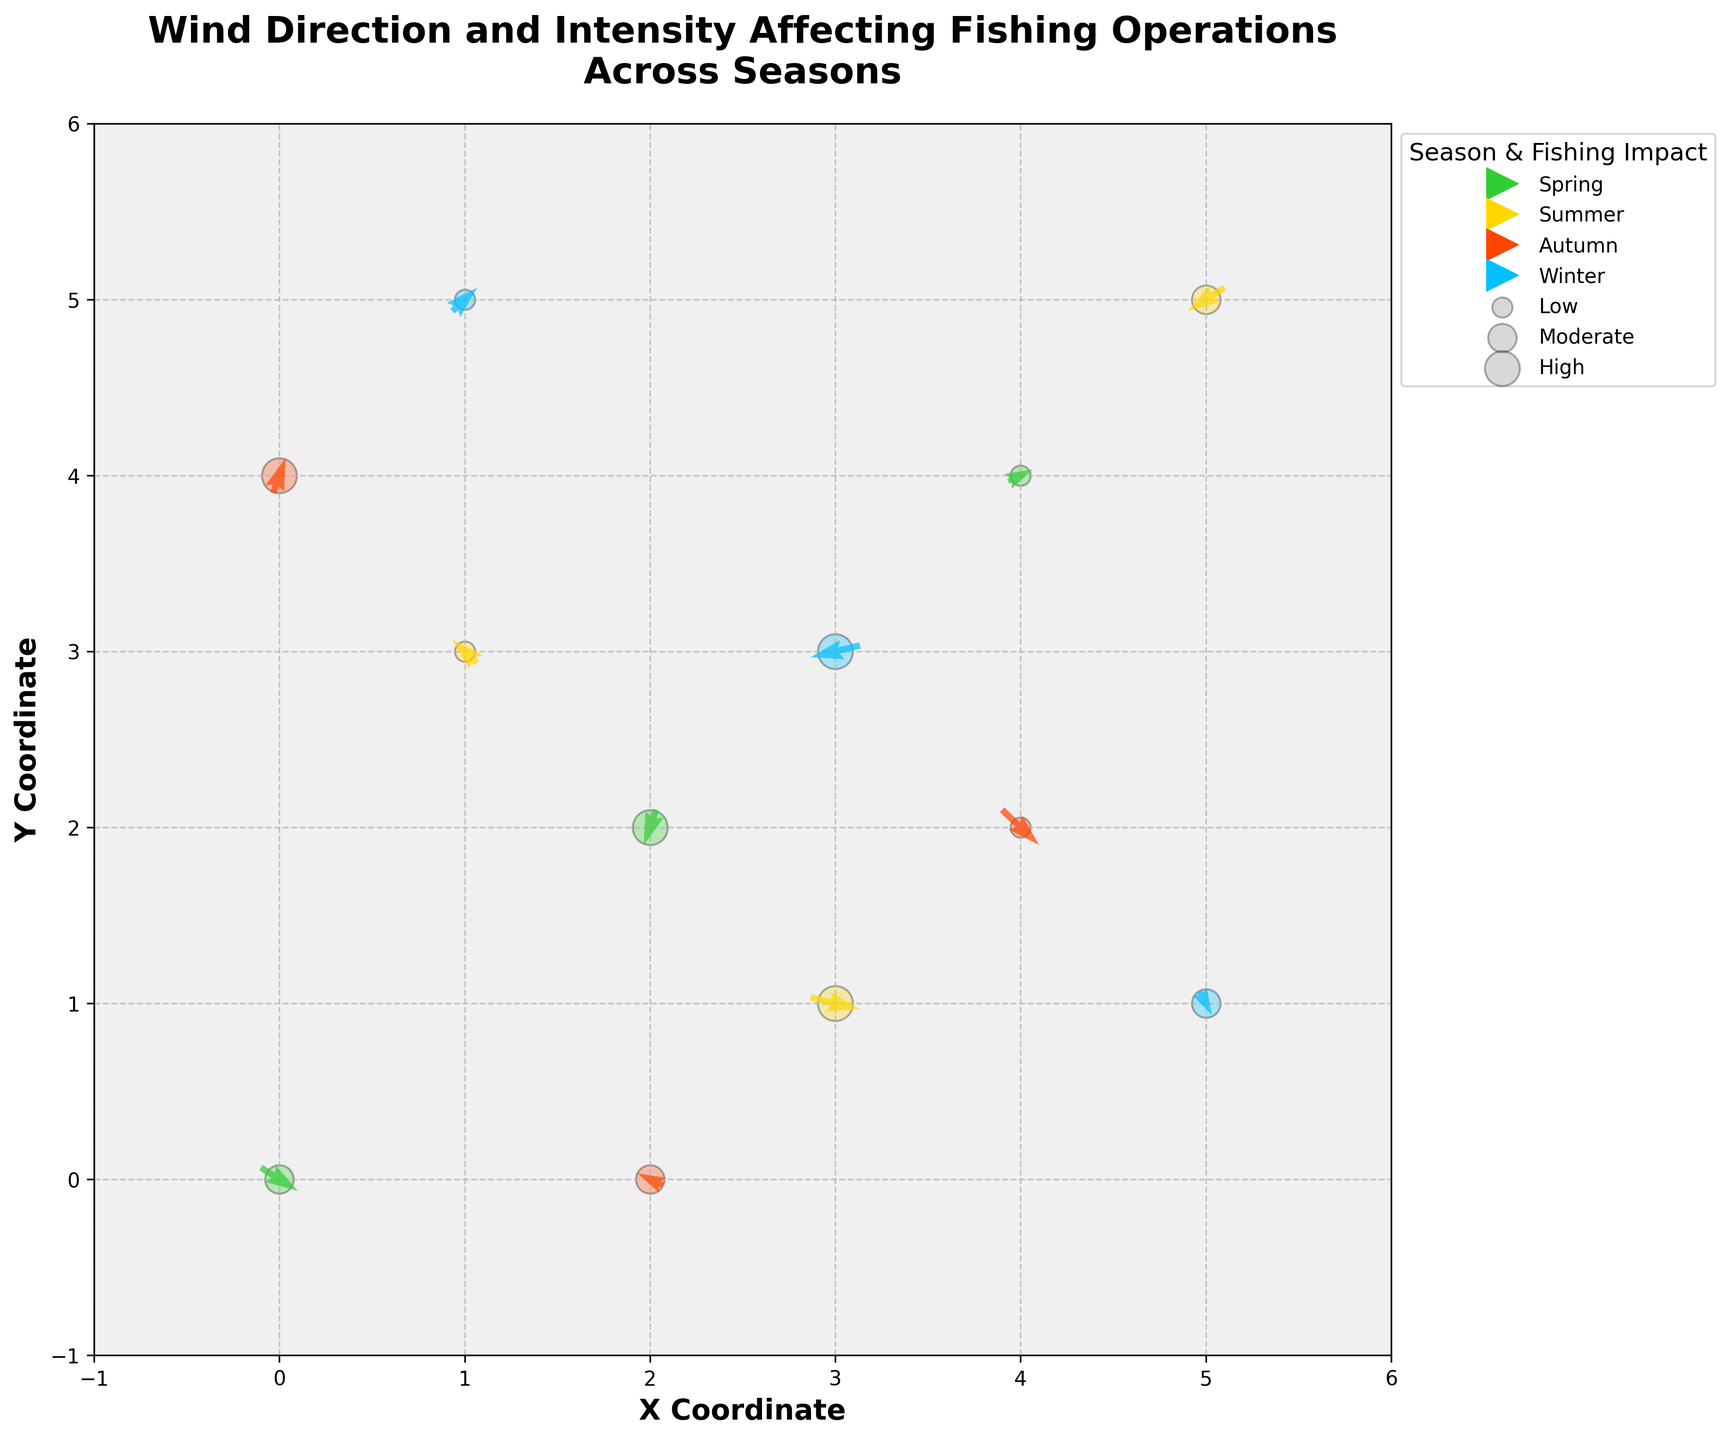What's the title of the plot? The title is shown at the top of the figure.
Answer: Wind Direction and Intensity Affecting Fishing Operations Across Seasons Which color represents the Summer season in the plot? The colors are identified by checking the legend.
Answer: Gold How many data points are there in the Winter season? Look at the length and location of arrows colored in 'deepskyblue' as indicated in the legend.
Answer: 3 What type of fishing impact is represented by the largest size of the scatter points? The legend shows different scatter point sizes and their corresponding fishing impact levels.
Answer: High Which season appears to have the highest instances of 'High' fishing impact? Count the number of scatter points sized 300 (high impact) for each season.
Answer: Winter Compare the wind intensity ('u' and 'v' vectors) between the Spring and Summer seasons at coordinates (2, 2) and (3, 1), respectively. Which has higher intensity? Use the Pythagorean theorem to compute the magnitude of the vectors at these coordinates for both seasons: Spring (√((-1)^2+(-3)^2) = √10) and Summer (√(4^2+(-1)^2) = √17).
Answer: Summer (3, 1) What's the overall trend in fishing impact during Autumn as observed from the plot? Observe the sizes of scatter points in Autumn (orangered).
Answer: Fishing impact is mixed during Autumn with 'High', 'Moderate', and 'Low' impacts present Does the direction of wind in Spring tend to reduce or enhance fishing impact? Check the scatter points sizes in Spring and the corresponding wind directions (arrows). Two out of three are moderate or high.
Answer: Reduce Between Autumn and Winter, which season has a more mixed (diversified) impact on fishing operations? Compare the variability in scatter point sizes between the two seasons; Autumn has all three: high, moderate, and low; Winter has high, moderate, and low as well.
Answer: Both have mixed impacts 